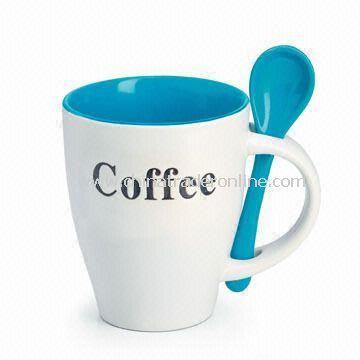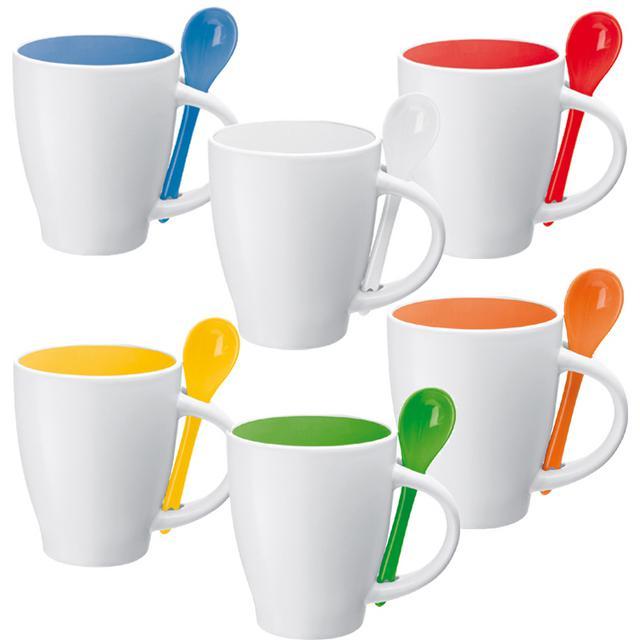The first image is the image on the left, the second image is the image on the right. Evaluate the accuracy of this statement regarding the images: "One image shows a single blue-lined white cup with a blue spoon.". Is it true? Answer yes or no. Yes. 